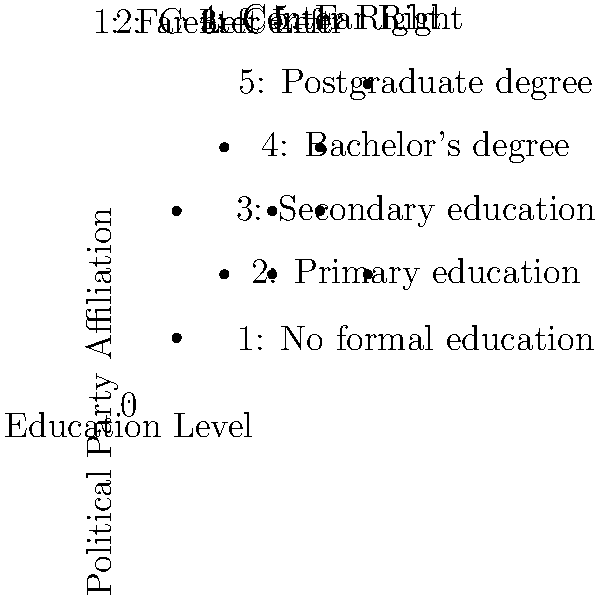Based on the scatter plot showing the relationship between education level and political party affiliation in Mexico, what is the Pearson correlation coefficient ($r$) between these two variables? Round your answer to two decimal places. To calculate the Pearson correlation coefficient ($r$), we need to follow these steps:

1. Calculate the mean of education level ($\bar{x}$) and political party affiliation ($\bar{y}$):
   $\bar{x} = (1+2+3+4+5+2+3+4+5+1) / 10 = 3$
   $\bar{y} = (1+2+3+4+5+4+2+3+2+3) / 10 = 2.9$

2. Calculate the deviations from the mean for each variable:
   $x_i - \bar{x}$ and $y_i - \bar{y}$

3. Calculate the product of the deviations:
   $(x_i - \bar{x})(y_i - \bar{y})$

4. Sum the products of deviations:
   $\sum (x_i - \bar{x})(y_i - \bar{y})$

5. Calculate the sum of squared deviations for each variable:
   $\sum (x_i - \bar{x})^2$ and $\sum (y_i - \bar{y})^2$

6. Apply the formula for Pearson correlation coefficient:
   $r = \frac{\sum (x_i - \bar{x})(y_i - \bar{y})}{\sqrt{\sum (x_i - \bar{x})^2 \sum (y_i - \bar{y})^2}}$

Calculating these values:

$\sum (x_i - \bar{x})(y_i - \bar{y}) = 8.9$
$\sum (x_i - \bar{x})^2 = 20$
$\sum (y_i - \bar{y})^2 = 13.9$

Substituting into the formula:

$r = \frac{8.9}{\sqrt{20 * 13.9}} = \frac{8.9}{\sqrt{278}} = \frac{8.9}{16.67} = 0.5339$

Rounding to two decimal places: $r = 0.53$
Answer: 0.53 